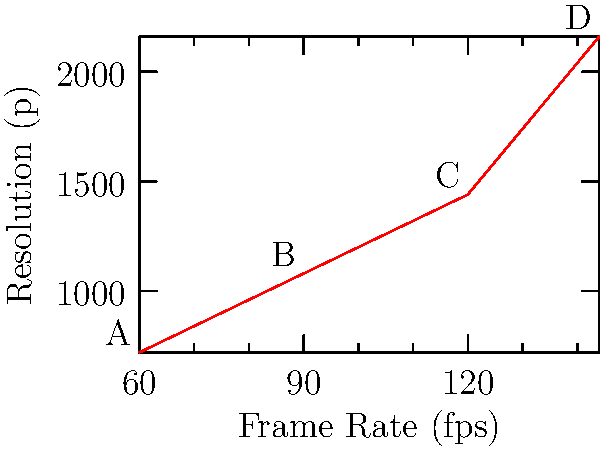The graph shows the relationship between frame rate and resolution for a VR display. If the maximum data transfer rate of the system is 311,040,000 pixels per second, which point on the graph represents the optimal configuration for this VR system? To solve this problem, we need to calculate the data transfer rate for each point and compare it to the maximum rate:

1. Calculate pixels per frame for each resolution:
   720p: 1280 × 720 = 921,600 pixels
   1080p: 1920 × 1080 = 2,073,600 pixels
   1440p: 2560 × 1440 = 3,686,400 pixels
   2160p: 3840 × 2160 = 8,294,400 pixels

2. Calculate data transfer rate for each point:
   A: 60 fps × 921,600 pixels = 55,296,000 pixels/s
   B: 90 fps × 2,073,600 pixels = 186,624,000 pixels/s
   C: 120 fps × 3,686,400 pixels = 442,368,000 pixels/s
   D: 144 fps × 8,294,400 pixels = 1,194,393,600 pixels/s

3. Compare with the maximum rate (311,040,000 pixels/s):
   A and B are below the maximum
   C and D exceed the maximum

4. Choose the highest quality configuration within the limit:
   Point B (90 fps, 1080p) is the optimal configuration, as it provides the highest quality while staying within the system's capabilities.
Answer: Point B (90 fps, 1080p) 